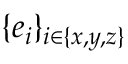Convert formula to latex. <formula><loc_0><loc_0><loc_500><loc_500>\{ e _ { i } \} _ { i \in \{ x , y , z \} }</formula> 